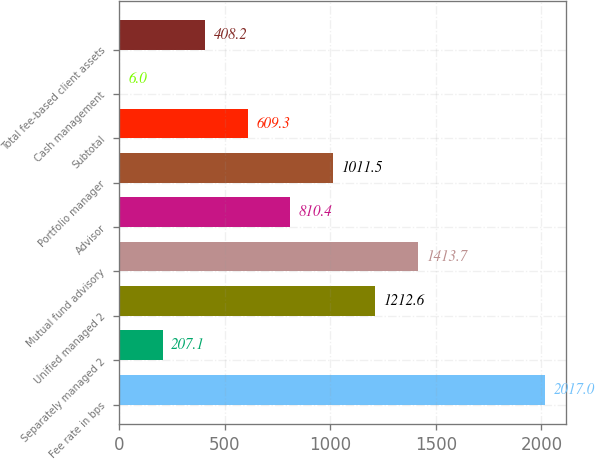Convert chart to OTSL. <chart><loc_0><loc_0><loc_500><loc_500><bar_chart><fcel>Fee rate in bps<fcel>Separately managed 2<fcel>Unified managed 2<fcel>Mutual fund advisory<fcel>Advisor<fcel>Portfolio manager<fcel>Subtotal<fcel>Cash management<fcel>Total fee-based client assets<nl><fcel>2017<fcel>207.1<fcel>1212.6<fcel>1413.7<fcel>810.4<fcel>1011.5<fcel>609.3<fcel>6<fcel>408.2<nl></chart> 